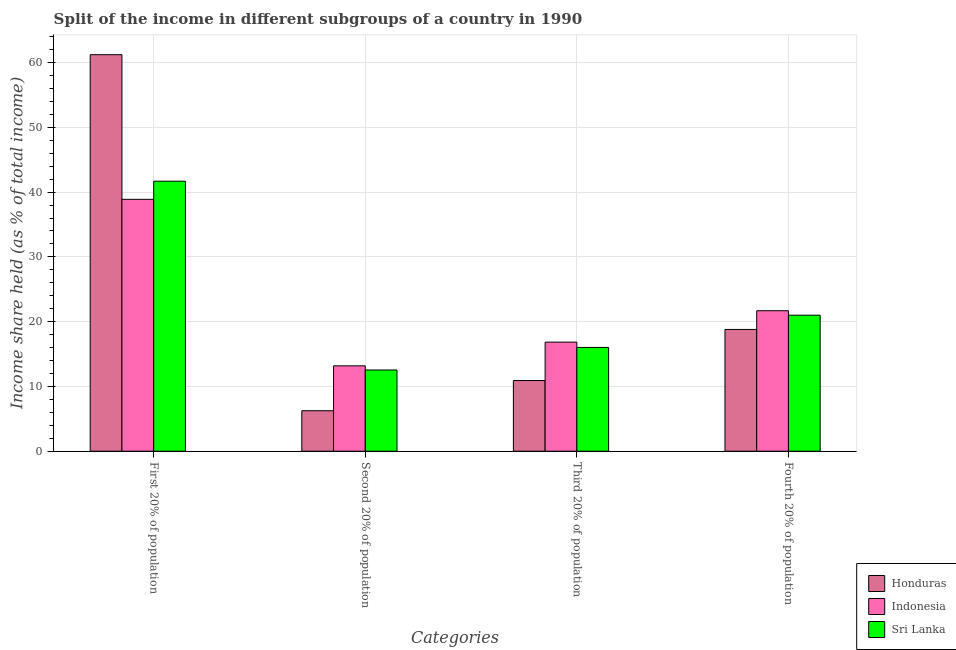How many bars are there on the 2nd tick from the right?
Provide a short and direct response. 3. What is the label of the 1st group of bars from the left?
Your answer should be compact. First 20% of population. What is the share of the income held by fourth 20% of the population in Indonesia?
Provide a succinct answer. 21.69. Across all countries, what is the maximum share of the income held by fourth 20% of the population?
Keep it short and to the point. 21.69. Across all countries, what is the minimum share of the income held by second 20% of the population?
Your answer should be very brief. 6.25. In which country was the share of the income held by second 20% of the population maximum?
Your response must be concise. Indonesia. What is the total share of the income held by first 20% of the population in the graph?
Your response must be concise. 141.8. What is the difference between the share of the income held by first 20% of the population in Indonesia and that in Sri Lanka?
Give a very brief answer. -2.8. What is the difference between the share of the income held by second 20% of the population in Indonesia and the share of the income held by first 20% of the population in Honduras?
Your answer should be very brief. -48.04. What is the average share of the income held by third 20% of the population per country?
Your response must be concise. 14.59. What is the difference between the share of the income held by second 20% of the population and share of the income held by fourth 20% of the population in Sri Lanka?
Provide a succinct answer. -8.46. In how many countries, is the share of the income held by fourth 20% of the population greater than 30 %?
Offer a very short reply. 0. What is the ratio of the share of the income held by fourth 20% of the population in Sri Lanka to that in Honduras?
Offer a terse response. 1.12. Is the difference between the share of the income held by fourth 20% of the population in Indonesia and Honduras greater than the difference between the share of the income held by second 20% of the population in Indonesia and Honduras?
Your answer should be very brief. No. What is the difference between the highest and the second highest share of the income held by second 20% of the population?
Keep it short and to the point. 0.64. What is the difference between the highest and the lowest share of the income held by fourth 20% of the population?
Provide a short and direct response. 2.89. In how many countries, is the share of the income held by third 20% of the population greater than the average share of the income held by third 20% of the population taken over all countries?
Your answer should be compact. 2. Is it the case that in every country, the sum of the share of the income held by first 20% of the population and share of the income held by second 20% of the population is greater than the sum of share of the income held by third 20% of the population and share of the income held by fourth 20% of the population?
Offer a terse response. Yes. What does the 1st bar from the left in First 20% of population represents?
Provide a short and direct response. Honduras. What does the 1st bar from the right in First 20% of population represents?
Provide a succinct answer. Sri Lanka. Are the values on the major ticks of Y-axis written in scientific E-notation?
Keep it short and to the point. No. Where does the legend appear in the graph?
Keep it short and to the point. Bottom right. What is the title of the graph?
Ensure brevity in your answer.  Split of the income in different subgroups of a country in 1990. Does "Syrian Arab Republic" appear as one of the legend labels in the graph?
Your answer should be very brief. No. What is the label or title of the X-axis?
Make the answer very short. Categories. What is the label or title of the Y-axis?
Your response must be concise. Income share held (as % of total income). What is the Income share held (as % of total income) in Honduras in First 20% of population?
Your response must be concise. 61.22. What is the Income share held (as % of total income) of Indonesia in First 20% of population?
Make the answer very short. 38.89. What is the Income share held (as % of total income) of Sri Lanka in First 20% of population?
Your answer should be compact. 41.69. What is the Income share held (as % of total income) of Honduras in Second 20% of population?
Make the answer very short. 6.25. What is the Income share held (as % of total income) in Indonesia in Second 20% of population?
Offer a terse response. 13.18. What is the Income share held (as % of total income) of Sri Lanka in Second 20% of population?
Give a very brief answer. 12.54. What is the Income share held (as % of total income) in Honduras in Third 20% of population?
Provide a succinct answer. 10.91. What is the Income share held (as % of total income) of Indonesia in Third 20% of population?
Give a very brief answer. 16.84. What is the Income share held (as % of total income) of Sri Lanka in Third 20% of population?
Your answer should be compact. 16.02. What is the Income share held (as % of total income) in Indonesia in Fourth 20% of population?
Keep it short and to the point. 21.69. Across all Categories, what is the maximum Income share held (as % of total income) in Honduras?
Offer a very short reply. 61.22. Across all Categories, what is the maximum Income share held (as % of total income) of Indonesia?
Keep it short and to the point. 38.89. Across all Categories, what is the maximum Income share held (as % of total income) in Sri Lanka?
Keep it short and to the point. 41.69. Across all Categories, what is the minimum Income share held (as % of total income) of Honduras?
Provide a short and direct response. 6.25. Across all Categories, what is the minimum Income share held (as % of total income) in Indonesia?
Provide a short and direct response. 13.18. Across all Categories, what is the minimum Income share held (as % of total income) of Sri Lanka?
Your answer should be compact. 12.54. What is the total Income share held (as % of total income) of Honduras in the graph?
Give a very brief answer. 97.18. What is the total Income share held (as % of total income) of Indonesia in the graph?
Your answer should be compact. 90.6. What is the total Income share held (as % of total income) of Sri Lanka in the graph?
Keep it short and to the point. 91.25. What is the difference between the Income share held (as % of total income) in Honduras in First 20% of population and that in Second 20% of population?
Provide a succinct answer. 54.97. What is the difference between the Income share held (as % of total income) in Indonesia in First 20% of population and that in Second 20% of population?
Offer a terse response. 25.71. What is the difference between the Income share held (as % of total income) of Sri Lanka in First 20% of population and that in Second 20% of population?
Offer a terse response. 29.15. What is the difference between the Income share held (as % of total income) of Honduras in First 20% of population and that in Third 20% of population?
Keep it short and to the point. 50.31. What is the difference between the Income share held (as % of total income) of Indonesia in First 20% of population and that in Third 20% of population?
Offer a very short reply. 22.05. What is the difference between the Income share held (as % of total income) in Sri Lanka in First 20% of population and that in Third 20% of population?
Offer a very short reply. 25.67. What is the difference between the Income share held (as % of total income) of Honduras in First 20% of population and that in Fourth 20% of population?
Offer a very short reply. 42.42. What is the difference between the Income share held (as % of total income) of Sri Lanka in First 20% of population and that in Fourth 20% of population?
Make the answer very short. 20.69. What is the difference between the Income share held (as % of total income) in Honduras in Second 20% of population and that in Third 20% of population?
Your response must be concise. -4.66. What is the difference between the Income share held (as % of total income) of Indonesia in Second 20% of population and that in Third 20% of population?
Offer a terse response. -3.66. What is the difference between the Income share held (as % of total income) in Sri Lanka in Second 20% of population and that in Third 20% of population?
Make the answer very short. -3.48. What is the difference between the Income share held (as % of total income) of Honduras in Second 20% of population and that in Fourth 20% of population?
Keep it short and to the point. -12.55. What is the difference between the Income share held (as % of total income) in Indonesia in Second 20% of population and that in Fourth 20% of population?
Keep it short and to the point. -8.51. What is the difference between the Income share held (as % of total income) of Sri Lanka in Second 20% of population and that in Fourth 20% of population?
Keep it short and to the point. -8.46. What is the difference between the Income share held (as % of total income) of Honduras in Third 20% of population and that in Fourth 20% of population?
Your answer should be compact. -7.89. What is the difference between the Income share held (as % of total income) of Indonesia in Third 20% of population and that in Fourth 20% of population?
Keep it short and to the point. -4.85. What is the difference between the Income share held (as % of total income) of Sri Lanka in Third 20% of population and that in Fourth 20% of population?
Make the answer very short. -4.98. What is the difference between the Income share held (as % of total income) in Honduras in First 20% of population and the Income share held (as % of total income) in Indonesia in Second 20% of population?
Your response must be concise. 48.04. What is the difference between the Income share held (as % of total income) in Honduras in First 20% of population and the Income share held (as % of total income) in Sri Lanka in Second 20% of population?
Ensure brevity in your answer.  48.68. What is the difference between the Income share held (as % of total income) in Indonesia in First 20% of population and the Income share held (as % of total income) in Sri Lanka in Second 20% of population?
Make the answer very short. 26.35. What is the difference between the Income share held (as % of total income) in Honduras in First 20% of population and the Income share held (as % of total income) in Indonesia in Third 20% of population?
Offer a terse response. 44.38. What is the difference between the Income share held (as % of total income) of Honduras in First 20% of population and the Income share held (as % of total income) of Sri Lanka in Third 20% of population?
Provide a succinct answer. 45.2. What is the difference between the Income share held (as % of total income) of Indonesia in First 20% of population and the Income share held (as % of total income) of Sri Lanka in Third 20% of population?
Provide a short and direct response. 22.87. What is the difference between the Income share held (as % of total income) in Honduras in First 20% of population and the Income share held (as % of total income) in Indonesia in Fourth 20% of population?
Provide a succinct answer. 39.53. What is the difference between the Income share held (as % of total income) of Honduras in First 20% of population and the Income share held (as % of total income) of Sri Lanka in Fourth 20% of population?
Make the answer very short. 40.22. What is the difference between the Income share held (as % of total income) of Indonesia in First 20% of population and the Income share held (as % of total income) of Sri Lanka in Fourth 20% of population?
Your answer should be compact. 17.89. What is the difference between the Income share held (as % of total income) of Honduras in Second 20% of population and the Income share held (as % of total income) of Indonesia in Third 20% of population?
Your answer should be compact. -10.59. What is the difference between the Income share held (as % of total income) of Honduras in Second 20% of population and the Income share held (as % of total income) of Sri Lanka in Third 20% of population?
Give a very brief answer. -9.77. What is the difference between the Income share held (as % of total income) in Indonesia in Second 20% of population and the Income share held (as % of total income) in Sri Lanka in Third 20% of population?
Your answer should be very brief. -2.84. What is the difference between the Income share held (as % of total income) in Honduras in Second 20% of population and the Income share held (as % of total income) in Indonesia in Fourth 20% of population?
Keep it short and to the point. -15.44. What is the difference between the Income share held (as % of total income) in Honduras in Second 20% of population and the Income share held (as % of total income) in Sri Lanka in Fourth 20% of population?
Your response must be concise. -14.75. What is the difference between the Income share held (as % of total income) in Indonesia in Second 20% of population and the Income share held (as % of total income) in Sri Lanka in Fourth 20% of population?
Your answer should be very brief. -7.82. What is the difference between the Income share held (as % of total income) of Honduras in Third 20% of population and the Income share held (as % of total income) of Indonesia in Fourth 20% of population?
Your answer should be compact. -10.78. What is the difference between the Income share held (as % of total income) of Honduras in Third 20% of population and the Income share held (as % of total income) of Sri Lanka in Fourth 20% of population?
Offer a very short reply. -10.09. What is the difference between the Income share held (as % of total income) in Indonesia in Third 20% of population and the Income share held (as % of total income) in Sri Lanka in Fourth 20% of population?
Offer a very short reply. -4.16. What is the average Income share held (as % of total income) of Honduras per Categories?
Offer a terse response. 24.3. What is the average Income share held (as % of total income) in Indonesia per Categories?
Provide a short and direct response. 22.65. What is the average Income share held (as % of total income) of Sri Lanka per Categories?
Offer a very short reply. 22.81. What is the difference between the Income share held (as % of total income) in Honduras and Income share held (as % of total income) in Indonesia in First 20% of population?
Ensure brevity in your answer.  22.33. What is the difference between the Income share held (as % of total income) in Honduras and Income share held (as % of total income) in Sri Lanka in First 20% of population?
Offer a very short reply. 19.53. What is the difference between the Income share held (as % of total income) of Honduras and Income share held (as % of total income) of Indonesia in Second 20% of population?
Your answer should be compact. -6.93. What is the difference between the Income share held (as % of total income) in Honduras and Income share held (as % of total income) in Sri Lanka in Second 20% of population?
Offer a very short reply. -6.29. What is the difference between the Income share held (as % of total income) of Indonesia and Income share held (as % of total income) of Sri Lanka in Second 20% of population?
Ensure brevity in your answer.  0.64. What is the difference between the Income share held (as % of total income) in Honduras and Income share held (as % of total income) in Indonesia in Third 20% of population?
Ensure brevity in your answer.  -5.93. What is the difference between the Income share held (as % of total income) of Honduras and Income share held (as % of total income) of Sri Lanka in Third 20% of population?
Offer a terse response. -5.11. What is the difference between the Income share held (as % of total income) of Indonesia and Income share held (as % of total income) of Sri Lanka in Third 20% of population?
Give a very brief answer. 0.82. What is the difference between the Income share held (as % of total income) in Honduras and Income share held (as % of total income) in Indonesia in Fourth 20% of population?
Give a very brief answer. -2.89. What is the difference between the Income share held (as % of total income) in Indonesia and Income share held (as % of total income) in Sri Lanka in Fourth 20% of population?
Your answer should be compact. 0.69. What is the ratio of the Income share held (as % of total income) of Honduras in First 20% of population to that in Second 20% of population?
Provide a succinct answer. 9.8. What is the ratio of the Income share held (as % of total income) in Indonesia in First 20% of population to that in Second 20% of population?
Ensure brevity in your answer.  2.95. What is the ratio of the Income share held (as % of total income) in Sri Lanka in First 20% of population to that in Second 20% of population?
Provide a short and direct response. 3.32. What is the ratio of the Income share held (as % of total income) of Honduras in First 20% of population to that in Third 20% of population?
Provide a succinct answer. 5.61. What is the ratio of the Income share held (as % of total income) of Indonesia in First 20% of population to that in Third 20% of population?
Your response must be concise. 2.31. What is the ratio of the Income share held (as % of total income) in Sri Lanka in First 20% of population to that in Third 20% of population?
Offer a very short reply. 2.6. What is the ratio of the Income share held (as % of total income) of Honduras in First 20% of population to that in Fourth 20% of population?
Provide a short and direct response. 3.26. What is the ratio of the Income share held (as % of total income) of Indonesia in First 20% of population to that in Fourth 20% of population?
Provide a succinct answer. 1.79. What is the ratio of the Income share held (as % of total income) of Sri Lanka in First 20% of population to that in Fourth 20% of population?
Keep it short and to the point. 1.99. What is the ratio of the Income share held (as % of total income) in Honduras in Second 20% of population to that in Third 20% of population?
Make the answer very short. 0.57. What is the ratio of the Income share held (as % of total income) in Indonesia in Second 20% of population to that in Third 20% of population?
Give a very brief answer. 0.78. What is the ratio of the Income share held (as % of total income) of Sri Lanka in Second 20% of population to that in Third 20% of population?
Provide a short and direct response. 0.78. What is the ratio of the Income share held (as % of total income) in Honduras in Second 20% of population to that in Fourth 20% of population?
Your answer should be compact. 0.33. What is the ratio of the Income share held (as % of total income) in Indonesia in Second 20% of population to that in Fourth 20% of population?
Ensure brevity in your answer.  0.61. What is the ratio of the Income share held (as % of total income) of Sri Lanka in Second 20% of population to that in Fourth 20% of population?
Provide a short and direct response. 0.6. What is the ratio of the Income share held (as % of total income) in Honduras in Third 20% of population to that in Fourth 20% of population?
Provide a succinct answer. 0.58. What is the ratio of the Income share held (as % of total income) of Indonesia in Third 20% of population to that in Fourth 20% of population?
Your response must be concise. 0.78. What is the ratio of the Income share held (as % of total income) of Sri Lanka in Third 20% of population to that in Fourth 20% of population?
Give a very brief answer. 0.76. What is the difference between the highest and the second highest Income share held (as % of total income) of Honduras?
Give a very brief answer. 42.42. What is the difference between the highest and the second highest Income share held (as % of total income) in Indonesia?
Offer a very short reply. 17.2. What is the difference between the highest and the second highest Income share held (as % of total income) of Sri Lanka?
Offer a terse response. 20.69. What is the difference between the highest and the lowest Income share held (as % of total income) of Honduras?
Your answer should be compact. 54.97. What is the difference between the highest and the lowest Income share held (as % of total income) in Indonesia?
Your answer should be compact. 25.71. What is the difference between the highest and the lowest Income share held (as % of total income) in Sri Lanka?
Offer a very short reply. 29.15. 